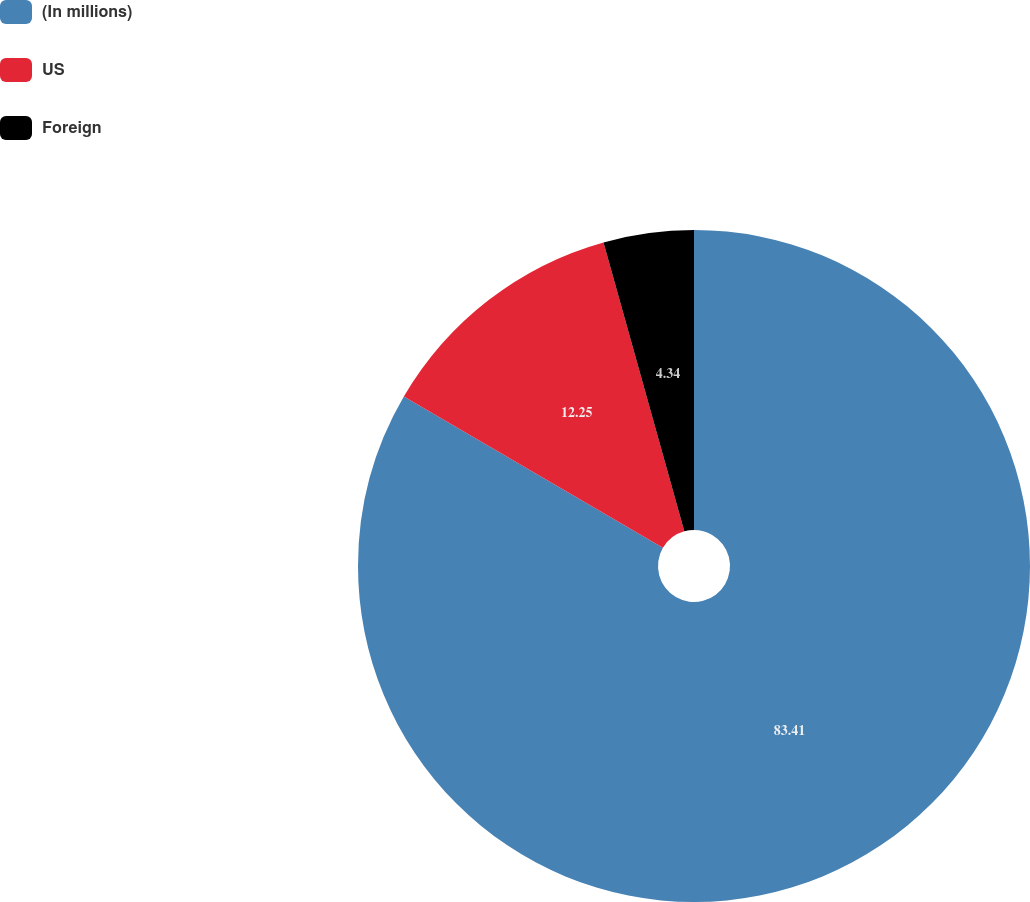Convert chart. <chart><loc_0><loc_0><loc_500><loc_500><pie_chart><fcel>(In millions)<fcel>US<fcel>Foreign<nl><fcel>83.41%<fcel>12.25%<fcel>4.34%<nl></chart> 